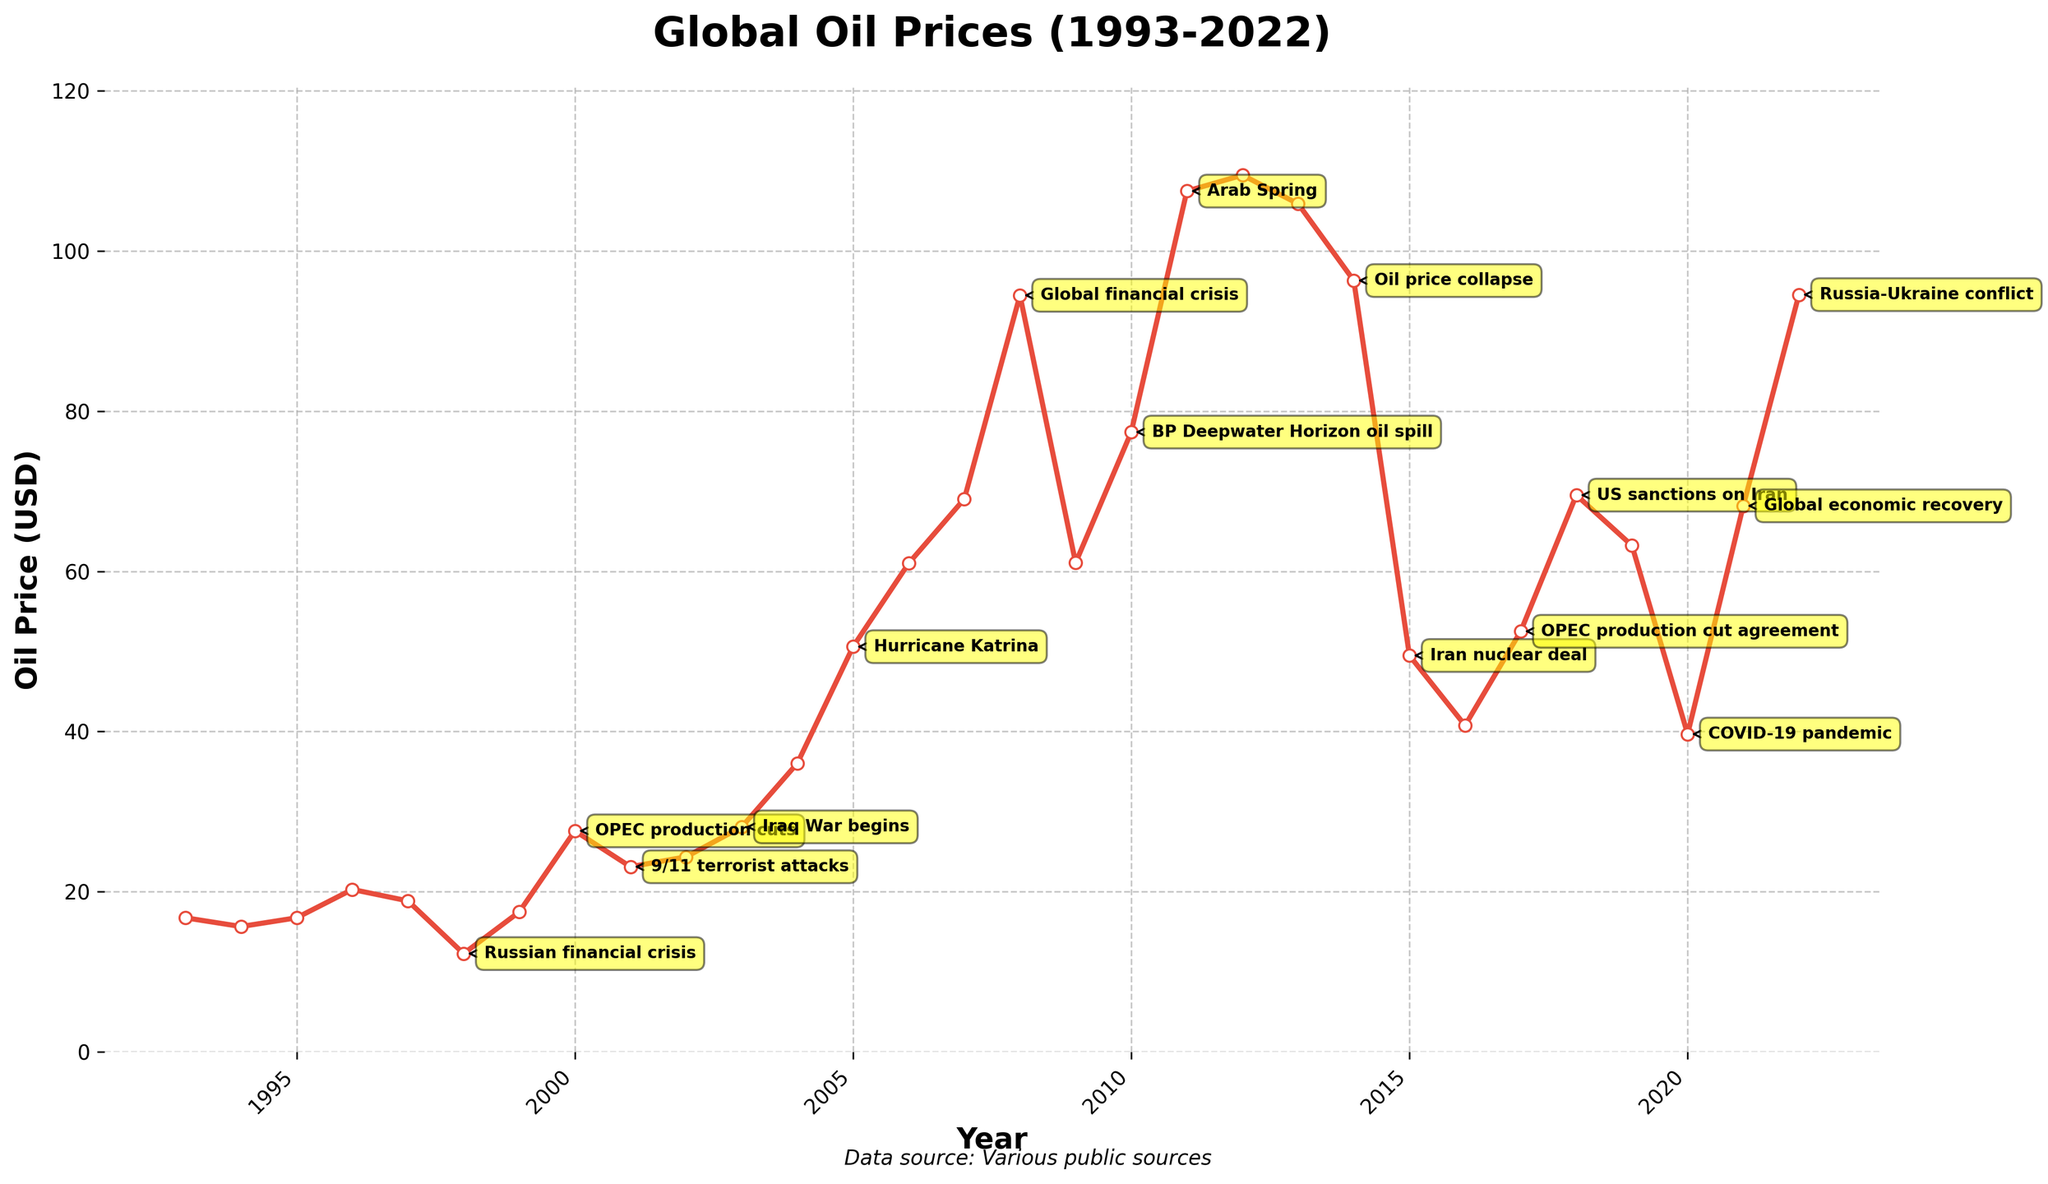What year did the oil price reach its highest point? The highest point on the line chart corresponds to the highest y-axis value of oil prices. Identifying this value's corresponding year tells us the year of the peak oil price.
Answer: 2012 Which major event is associated with a significant drop in oil prices after 2014? Locate 2014 on the x-axis and identify the steep decline in prices. Then, check the annotations for the event that aligns with this decline.
Answer: Iran nuclear deal How many times did oil prices drop after major geopolitical events? Review each annotated event on the chart and observe the trend of oil prices immediately after each event to determine if there was a notable decline. Count these occurrences.
Answer: 6 What was the oil price in 2008, and what event is associated with that year? Find the data point for 2008 on the x-axis; the annotation directly above or near this point will indicate the event. Read the corresponding oil price from the y-axis.
Answer: 94.45 USD, Global financial crisis Which event corresponds with the lowest oil price in the dataset? Identify the lowest point on the line chart and check for the nearest annotation.
Answer: Russian financial crisis What is the average oil price from 2008 to 2012? Identify the oil prices from 2008, 2009, 2010, 2011, and 2012. Add these values and divide by 5 to get the average.
Answer: 86.94 USD Compare the oil prices between 1998 and 2020, and determine which year had a higher price. Locate and compare the values for 1998 and 2020 on the y-axis to see which one is higher.
Answer: 2020 How do the oil prices in 2005 and 2009 compare? Find the oil price value associated with 2005 and compare it with the value for 2009 to determine which is higher.
Answer: 2005 Did the oil price increase or decrease after Hurricane Katrina in 2005, and by how much? Find the data points for 2005 and 2006, subtract the 2005 price from the 2006 price to see the change. If the result is positive, it increased; if negative, it decreased.
Answer: Increased by 10.41 USD What are the three most significant drops in oil prices and the corresponding events? Scan the line chart for the steepest declines, check annotations for the associated events, and identify three major ones.
Answer: Global financial crisis (2008), Oil price collapse (2014), COVID-19 pandemic (2020) 